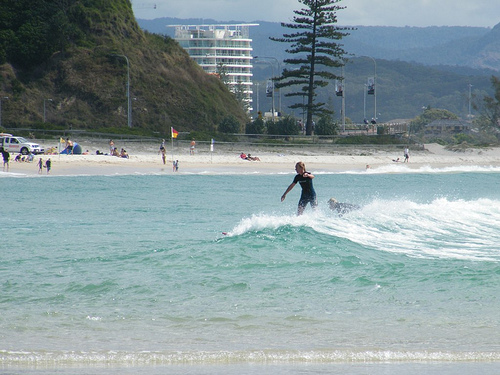Use your imagination to describe a story happening in this scene. In this picturesque seaside town, a surfing competition is underway. The girl on the surfboard, Anna, is catching a wave with perfect balance and form. On the beach, a flag flutters in the wind, marking the competition's zone, while spectators cheer from the sandy shore. In the water nearby, a seasoned surfer named Mike is basking in the shallow waves, reminiscing about his early surfing days. The beach scene is completed by a parked lifeguard vehicle, ready to ensure everyone's safety. Meanwhile, in the backdrop, there's a tall building nestled behind a lush hill, overlooking the entire event. This vibrant scene is bustling with energy as surfers, beachgoers, and nature lovers come together to enjoy a day of fun in the sun. 